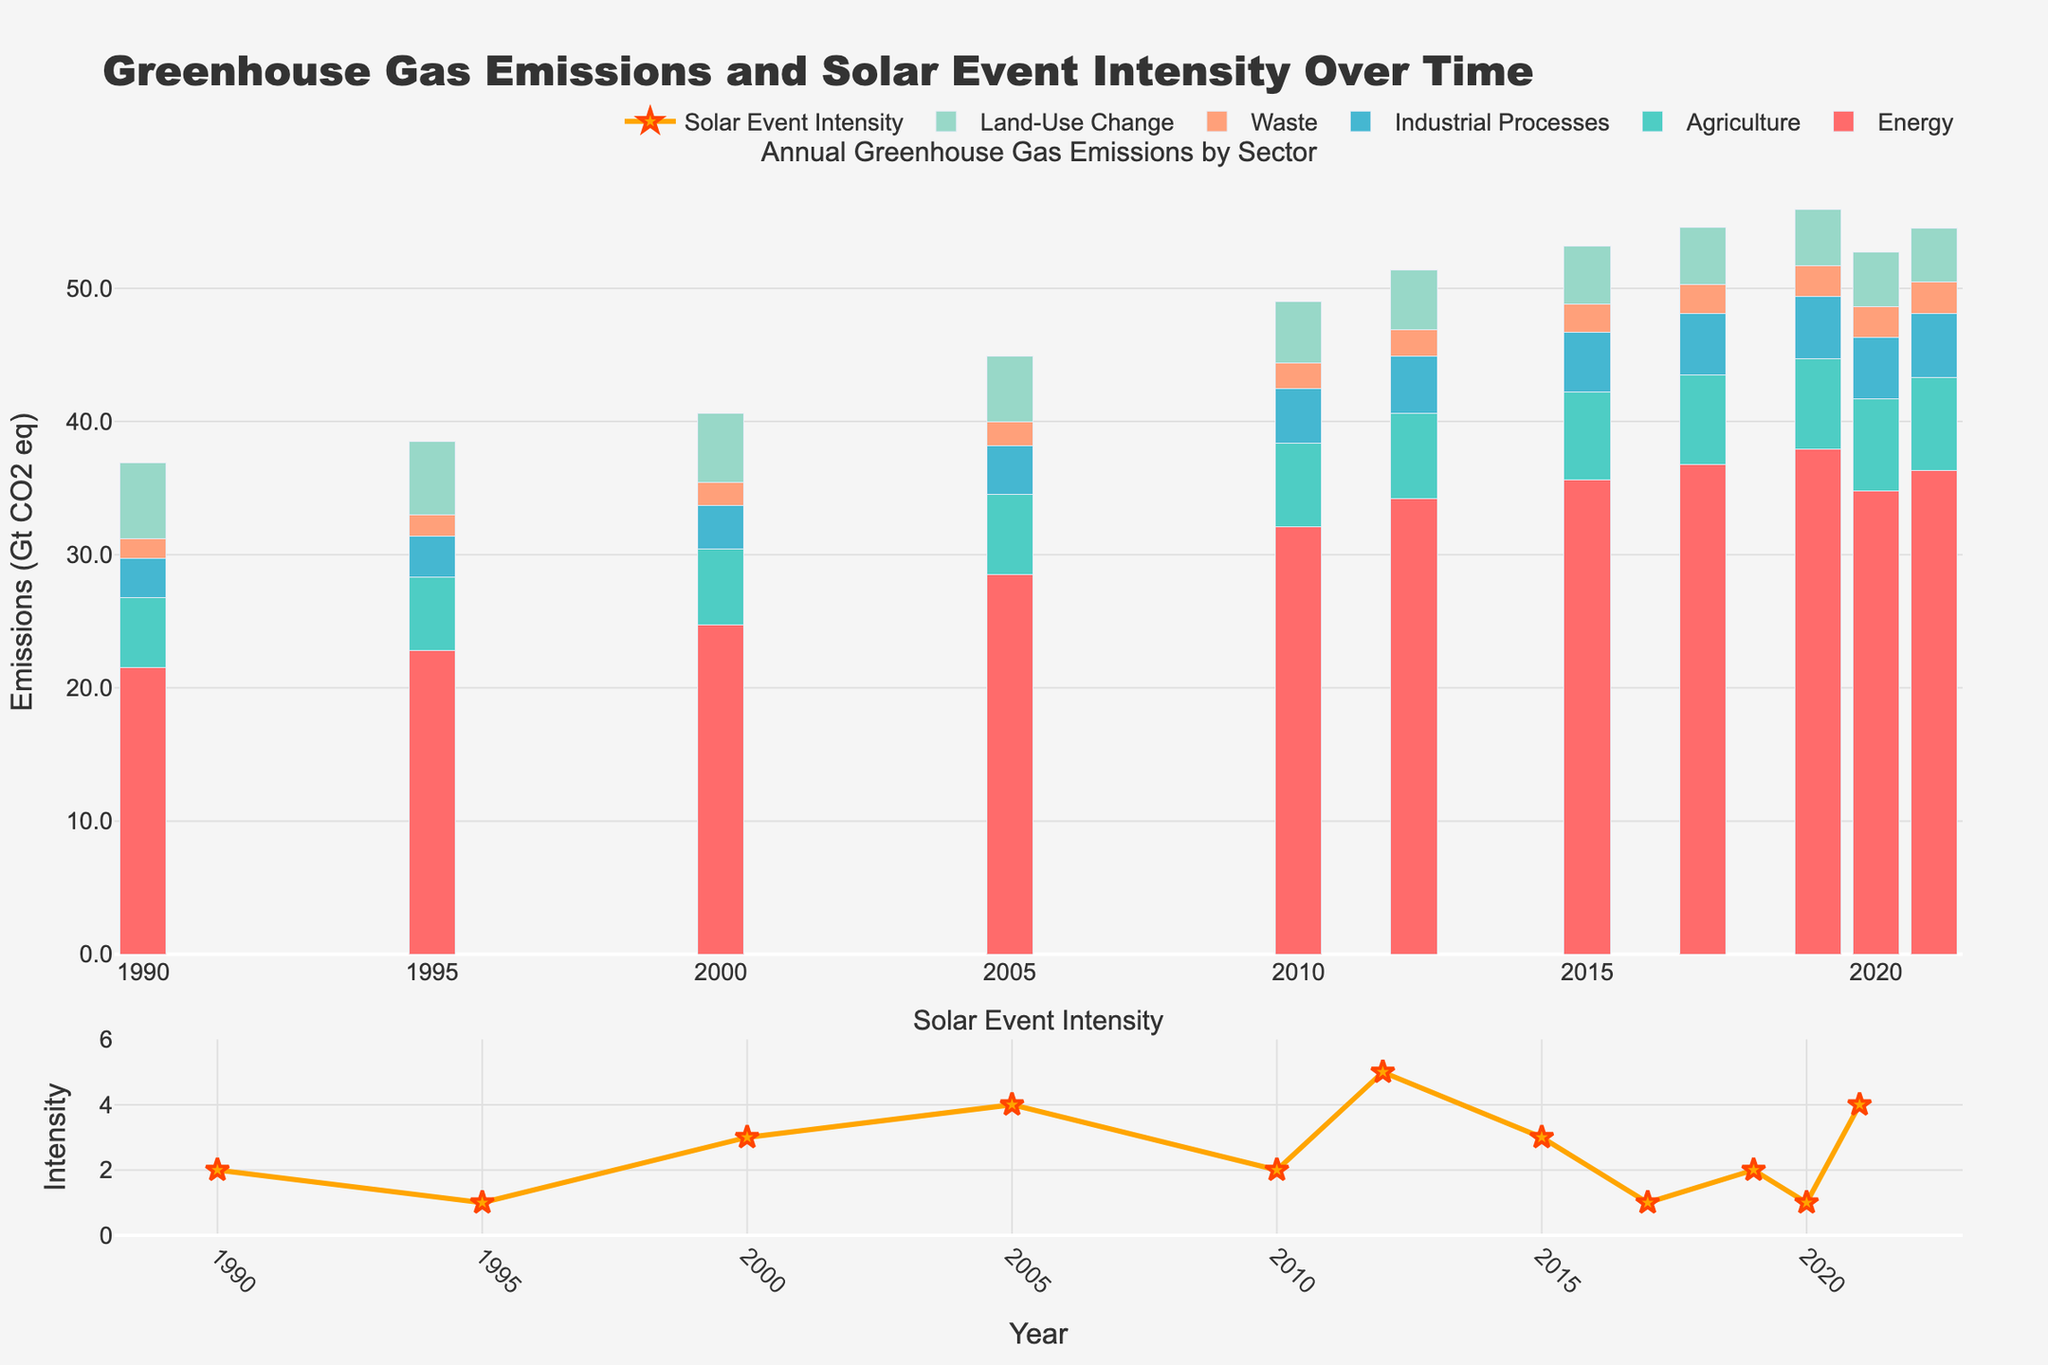What's the trend of greenhouse gas emissions from the Energy sector from 1990 to 2021? To determine the trend, observe the heights of the bars representing the Energy sector over the years. The heights increase consistently from 1990 to 2021, with a slight dip in 2020, indicating a general upward trend.
Answer: Increasing How does the emissions from Industrial Processes in 1990 compare to those in 2021? Compare the height of the bars for Industrial Processes in 1990 and 2021. The 1990 emissions are 2.9, while in 2021 they are 4.8. This tells us that emissions from Industrial Processes increased by 1.9 throughout the period.
Answer: Industrial Processes emissions increased What is the difference in emissions from the Agriculture sector between 2000 and 2021? Look at the Agriculture bars for 2000 (5.7) and 2021 (7.0). Subtract the 2000 value from the 2021 value: 7.0 - 5.7 = 1.3.
Answer: 1.3 What's the average Solar Event Intensity over the years depicted? Add the Solar Event Intensity values from each year and divide by the number of years. The total is 2+1+3+4+2+5+3+1+2+1+4 = 28. There are 11 years, so the average is 28/11 ≈ 2.55.
Answer: Around 2.55 During which year(s) did Energy sector emissions see the highest single-year increase? Compare the increases in Energy sector emissions between consecutive years. The largest increase is between 2000 (24.7) and 2005 (28.5), which is 3.8.
Answer: 2000-2005 In which year was the Solar Event Intensity highest, and what was its value? Identify the peak value in the Solar Event Intensity graph, which occurs in 2012 with a value of 5.
Answer: 2012, 5 Which sector exhibited the smallest change in emissions from 1990 to 2021? To determine the smallest change, compare the difference in the emissions of each sector between 1990 and 2021. The Waste sector changed from 1.5 to 2.4, a difference of 0.9, which is the smallest when compared to other sectors.
Answer: Waste In 2020, which sector saw the largest drop in emissions compared to the previous year? Compare the emissions of each sector in 2019 and 2020. The Energy sector drops from 37.9 in 2019 to 34.8 in 2020, the largest drop of 3.1 units.
Answer: Energy Combining the emissions from Agriculture and Waste sectors, what is the total emissions in 2010? Add the emissions from Agriculture (6.3) and Waste (1.9) for 2010: 6.3 + 1.9 = 8.2.
Answer: 8.2 